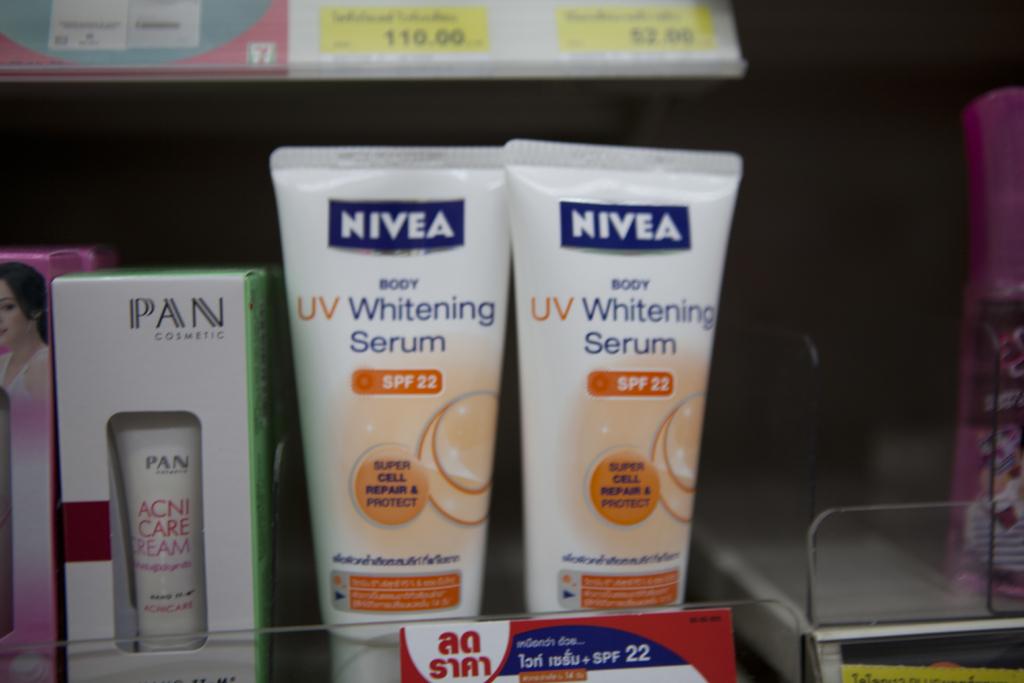What company makes this serum?
Offer a very short reply. Nivea. 